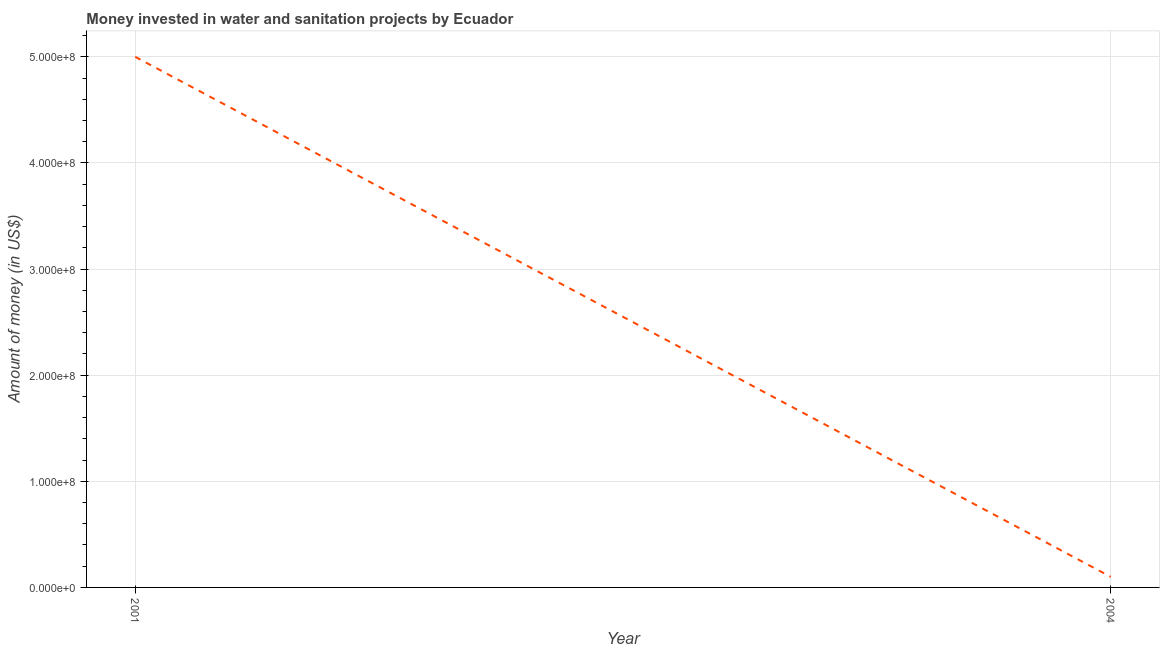What is the investment in 2004?
Offer a very short reply. 1.00e+07. Across all years, what is the maximum investment?
Your answer should be compact. 5.00e+08. Across all years, what is the minimum investment?
Your response must be concise. 1.00e+07. In which year was the investment maximum?
Provide a short and direct response. 2001. What is the sum of the investment?
Provide a short and direct response. 5.10e+08. What is the difference between the investment in 2001 and 2004?
Make the answer very short. 4.90e+08. What is the average investment per year?
Your response must be concise. 2.55e+08. What is the median investment?
Ensure brevity in your answer.  2.55e+08. In how many years, is the investment greater than 120000000 US$?
Provide a short and direct response. 1. Is the investment in 2001 less than that in 2004?
Provide a succinct answer. No. How many lines are there?
Your response must be concise. 1. How many years are there in the graph?
Offer a very short reply. 2. What is the difference between two consecutive major ticks on the Y-axis?
Your answer should be very brief. 1.00e+08. What is the title of the graph?
Make the answer very short. Money invested in water and sanitation projects by Ecuador. What is the label or title of the X-axis?
Give a very brief answer. Year. What is the label or title of the Y-axis?
Provide a succinct answer. Amount of money (in US$). What is the difference between the Amount of money (in US$) in 2001 and 2004?
Make the answer very short. 4.90e+08. What is the ratio of the Amount of money (in US$) in 2001 to that in 2004?
Give a very brief answer. 50. 